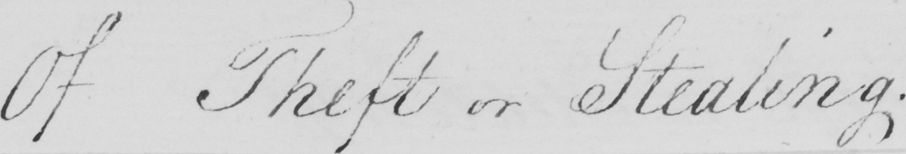Can you read and transcribe this handwriting? Of Theft or Stealing . 